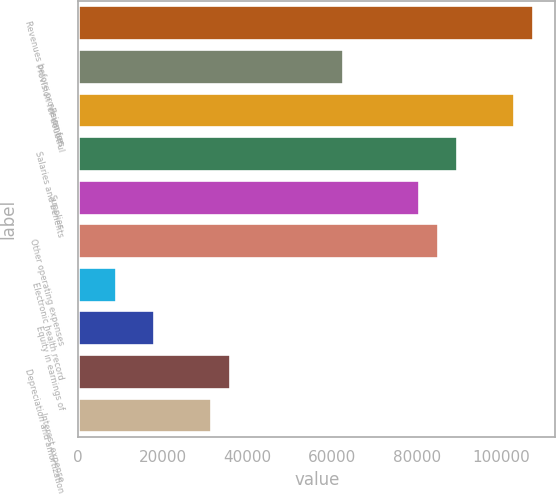<chart> <loc_0><loc_0><loc_500><loc_500><bar_chart><fcel>Revenues before provision for<fcel>Provision for doubtful<fcel>Revenues<fcel>Salaries and benefits<fcel>Supplies<fcel>Other operating expenses<fcel>Electronic health record<fcel>Equity in earnings of<fcel>Depreciation and amortization<fcel>Interest expense<nl><fcel>107383<fcel>62642.9<fcel>102909<fcel>89486.7<fcel>80538.8<fcel>85012.7<fcel>8955.24<fcel>17903.2<fcel>35799.1<fcel>31325.1<nl></chart> 